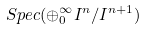<formula> <loc_0><loc_0><loc_500><loc_500>S p e c ( \oplus _ { 0 } ^ { \infty } I ^ { n } / I ^ { n + 1 } )</formula> 